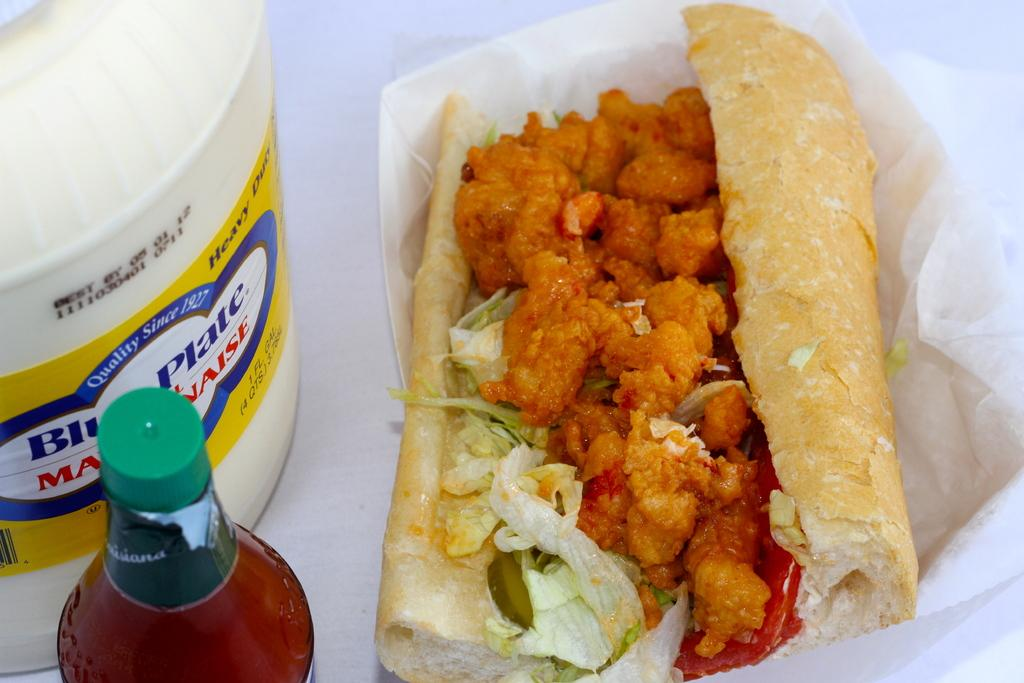What is the main subject of the image? The main subject of the image is food. How is the food being presented? The food is presented in a bowl. Are there any other objects visible in the image? Yes, there are two bottles in the image. How is the food being emphasized or highlighted? The food is highlighted, but the specific method is not mentioned in the facts. Can you see any sleet or streams in the image? No, there is no mention of sleet or streams in the image. The image features food presented in a bowl and two bottles. 